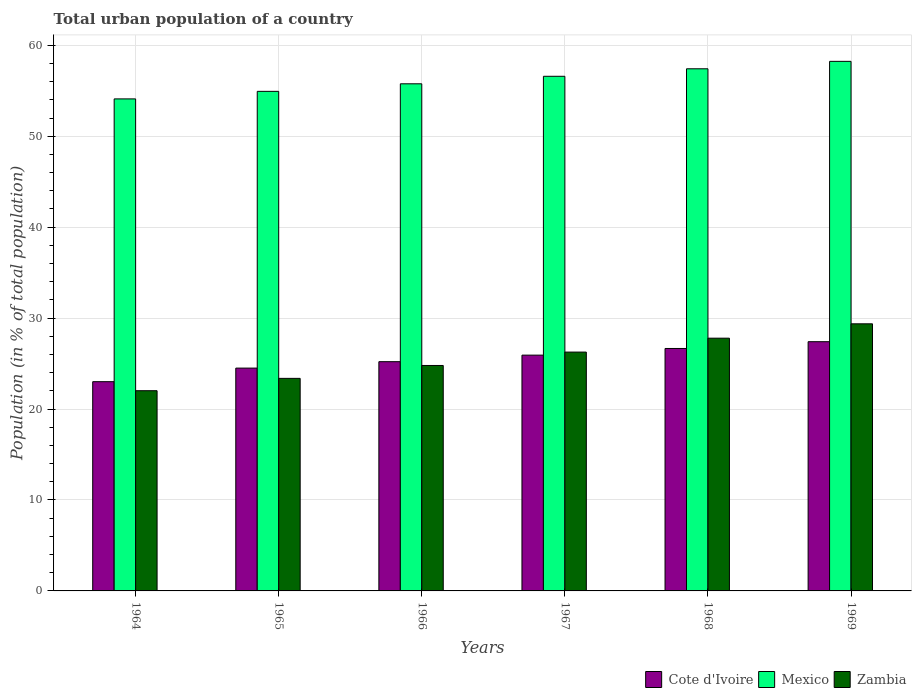How many different coloured bars are there?
Your answer should be very brief. 3. How many groups of bars are there?
Your response must be concise. 6. How many bars are there on the 3rd tick from the right?
Your answer should be compact. 3. What is the label of the 1st group of bars from the left?
Your response must be concise. 1964. In how many cases, is the number of bars for a given year not equal to the number of legend labels?
Keep it short and to the point. 0. What is the urban population in Cote d'Ivoire in 1967?
Make the answer very short. 25.93. Across all years, what is the maximum urban population in Cote d'Ivoire?
Offer a very short reply. 27.4. Across all years, what is the minimum urban population in Cote d'Ivoire?
Ensure brevity in your answer.  23.01. In which year was the urban population in Zambia maximum?
Offer a very short reply. 1969. In which year was the urban population in Mexico minimum?
Your answer should be compact. 1964. What is the total urban population in Mexico in the graph?
Make the answer very short. 337.02. What is the difference between the urban population in Mexico in 1967 and that in 1969?
Offer a terse response. -1.64. What is the difference between the urban population in Mexico in 1969 and the urban population in Zambia in 1964?
Keep it short and to the point. 36.21. What is the average urban population in Mexico per year?
Ensure brevity in your answer.  56.17. In the year 1965, what is the difference between the urban population in Cote d'Ivoire and urban population in Mexico?
Keep it short and to the point. -30.43. What is the ratio of the urban population in Cote d'Ivoire in 1965 to that in 1966?
Offer a very short reply. 0.97. Is the urban population in Mexico in 1964 less than that in 1965?
Provide a short and direct response. Yes. What is the difference between the highest and the second highest urban population in Mexico?
Give a very brief answer. 0.82. What is the difference between the highest and the lowest urban population in Zambia?
Offer a terse response. 7.36. What does the 1st bar from the left in 1966 represents?
Provide a succinct answer. Cote d'Ivoire. What does the 1st bar from the right in 1969 represents?
Your response must be concise. Zambia. How many bars are there?
Provide a succinct answer. 18. Are all the bars in the graph horizontal?
Your response must be concise. No. What is the difference between two consecutive major ticks on the Y-axis?
Offer a very short reply. 10. Are the values on the major ticks of Y-axis written in scientific E-notation?
Give a very brief answer. No. Does the graph contain any zero values?
Your answer should be compact. No. Does the graph contain grids?
Offer a terse response. Yes. How are the legend labels stacked?
Provide a short and direct response. Horizontal. What is the title of the graph?
Provide a succinct answer. Total urban population of a country. What is the label or title of the X-axis?
Offer a terse response. Years. What is the label or title of the Y-axis?
Your response must be concise. Population (in % of total population). What is the Population (in % of total population) of Cote d'Ivoire in 1964?
Give a very brief answer. 23.01. What is the Population (in % of total population) in Mexico in 1964?
Ensure brevity in your answer.  54.1. What is the Population (in % of total population) of Zambia in 1964?
Provide a succinct answer. 22.02. What is the Population (in % of total population) of Cote d'Ivoire in 1965?
Your response must be concise. 24.5. What is the Population (in % of total population) in Mexico in 1965?
Your response must be concise. 54.93. What is the Population (in % of total population) in Zambia in 1965?
Keep it short and to the point. 23.37. What is the Population (in % of total population) of Cote d'Ivoire in 1966?
Offer a terse response. 25.21. What is the Population (in % of total population) of Mexico in 1966?
Offer a very short reply. 55.76. What is the Population (in % of total population) of Zambia in 1966?
Keep it short and to the point. 24.79. What is the Population (in % of total population) of Cote d'Ivoire in 1967?
Your answer should be very brief. 25.93. What is the Population (in % of total population) in Mexico in 1967?
Provide a short and direct response. 56.59. What is the Population (in % of total population) in Zambia in 1967?
Give a very brief answer. 26.26. What is the Population (in % of total population) in Cote d'Ivoire in 1968?
Your response must be concise. 26.66. What is the Population (in % of total population) of Mexico in 1968?
Offer a terse response. 57.41. What is the Population (in % of total population) in Zambia in 1968?
Give a very brief answer. 27.79. What is the Population (in % of total population) in Cote d'Ivoire in 1969?
Offer a terse response. 27.4. What is the Population (in % of total population) of Mexico in 1969?
Offer a terse response. 58.23. What is the Population (in % of total population) of Zambia in 1969?
Your response must be concise. 29.37. Across all years, what is the maximum Population (in % of total population) in Cote d'Ivoire?
Make the answer very short. 27.4. Across all years, what is the maximum Population (in % of total population) in Mexico?
Make the answer very short. 58.23. Across all years, what is the maximum Population (in % of total population) of Zambia?
Your answer should be very brief. 29.37. Across all years, what is the minimum Population (in % of total population) in Cote d'Ivoire?
Make the answer very short. 23.01. Across all years, what is the minimum Population (in % of total population) in Mexico?
Give a very brief answer. 54.1. Across all years, what is the minimum Population (in % of total population) of Zambia?
Provide a short and direct response. 22.02. What is the total Population (in % of total population) of Cote d'Ivoire in the graph?
Your answer should be very brief. 152.7. What is the total Population (in % of total population) in Mexico in the graph?
Your answer should be very brief. 337.02. What is the total Population (in % of total population) of Zambia in the graph?
Keep it short and to the point. 153.6. What is the difference between the Population (in % of total population) in Cote d'Ivoire in 1964 and that in 1965?
Make the answer very short. -1.49. What is the difference between the Population (in % of total population) in Mexico in 1964 and that in 1965?
Ensure brevity in your answer.  -0.83. What is the difference between the Population (in % of total population) of Zambia in 1964 and that in 1965?
Give a very brief answer. -1.36. What is the difference between the Population (in % of total population) of Cote d'Ivoire in 1964 and that in 1966?
Your answer should be very brief. -2.2. What is the difference between the Population (in % of total population) in Mexico in 1964 and that in 1966?
Offer a very short reply. -1.66. What is the difference between the Population (in % of total population) of Zambia in 1964 and that in 1966?
Provide a short and direct response. -2.77. What is the difference between the Population (in % of total population) in Cote d'Ivoire in 1964 and that in 1967?
Your answer should be compact. -2.92. What is the difference between the Population (in % of total population) in Mexico in 1964 and that in 1967?
Make the answer very short. -2.49. What is the difference between the Population (in % of total population) in Zambia in 1964 and that in 1967?
Provide a succinct answer. -4.25. What is the difference between the Population (in % of total population) in Cote d'Ivoire in 1964 and that in 1968?
Your response must be concise. -3.65. What is the difference between the Population (in % of total population) of Mexico in 1964 and that in 1968?
Provide a short and direct response. -3.31. What is the difference between the Population (in % of total population) of Zambia in 1964 and that in 1968?
Your answer should be very brief. -5.78. What is the difference between the Population (in % of total population) of Cote d'Ivoire in 1964 and that in 1969?
Offer a terse response. -4.4. What is the difference between the Population (in % of total population) of Mexico in 1964 and that in 1969?
Offer a very short reply. -4.13. What is the difference between the Population (in % of total population) in Zambia in 1964 and that in 1969?
Keep it short and to the point. -7.36. What is the difference between the Population (in % of total population) of Cote d'Ivoire in 1965 and that in 1966?
Give a very brief answer. -0.71. What is the difference between the Population (in % of total population) of Mexico in 1965 and that in 1966?
Offer a terse response. -0.83. What is the difference between the Population (in % of total population) in Zambia in 1965 and that in 1966?
Provide a succinct answer. -1.42. What is the difference between the Population (in % of total population) of Cote d'Ivoire in 1965 and that in 1967?
Ensure brevity in your answer.  -1.43. What is the difference between the Population (in % of total population) of Mexico in 1965 and that in 1967?
Offer a terse response. -1.66. What is the difference between the Population (in % of total population) in Zambia in 1965 and that in 1967?
Provide a short and direct response. -2.89. What is the difference between the Population (in % of total population) in Cote d'Ivoire in 1965 and that in 1968?
Give a very brief answer. -2.16. What is the difference between the Population (in % of total population) of Mexico in 1965 and that in 1968?
Make the answer very short. -2.48. What is the difference between the Population (in % of total population) of Zambia in 1965 and that in 1968?
Your answer should be compact. -4.42. What is the difference between the Population (in % of total population) of Cote d'Ivoire in 1965 and that in 1969?
Keep it short and to the point. -2.9. What is the difference between the Population (in % of total population) in Mexico in 1965 and that in 1969?
Your response must be concise. -3.3. What is the difference between the Population (in % of total population) in Zambia in 1965 and that in 1969?
Offer a terse response. -6. What is the difference between the Population (in % of total population) of Cote d'Ivoire in 1966 and that in 1967?
Keep it short and to the point. -0.72. What is the difference between the Population (in % of total population) in Mexico in 1966 and that in 1967?
Your response must be concise. -0.83. What is the difference between the Population (in % of total population) of Zambia in 1966 and that in 1967?
Your answer should be compact. -1.47. What is the difference between the Population (in % of total population) in Cote d'Ivoire in 1966 and that in 1968?
Give a very brief answer. -1.45. What is the difference between the Population (in % of total population) of Mexico in 1966 and that in 1968?
Your response must be concise. -1.65. What is the difference between the Population (in % of total population) in Zambia in 1966 and that in 1968?
Provide a short and direct response. -3. What is the difference between the Population (in % of total population) in Cote d'Ivoire in 1966 and that in 1969?
Ensure brevity in your answer.  -2.2. What is the difference between the Population (in % of total population) in Mexico in 1966 and that in 1969?
Offer a terse response. -2.47. What is the difference between the Population (in % of total population) of Zambia in 1966 and that in 1969?
Your answer should be very brief. -4.58. What is the difference between the Population (in % of total population) in Cote d'Ivoire in 1967 and that in 1968?
Make the answer very short. -0.73. What is the difference between the Population (in % of total population) in Mexico in 1967 and that in 1968?
Offer a terse response. -0.82. What is the difference between the Population (in % of total population) of Zambia in 1967 and that in 1968?
Ensure brevity in your answer.  -1.53. What is the difference between the Population (in % of total population) of Cote d'Ivoire in 1967 and that in 1969?
Provide a succinct answer. -1.48. What is the difference between the Population (in % of total population) of Mexico in 1967 and that in 1969?
Your answer should be very brief. -1.64. What is the difference between the Population (in % of total population) of Zambia in 1967 and that in 1969?
Provide a short and direct response. -3.11. What is the difference between the Population (in % of total population) of Cote d'Ivoire in 1968 and that in 1969?
Make the answer very short. -0.74. What is the difference between the Population (in % of total population) of Mexico in 1968 and that in 1969?
Offer a very short reply. -0.82. What is the difference between the Population (in % of total population) in Zambia in 1968 and that in 1969?
Keep it short and to the point. -1.58. What is the difference between the Population (in % of total population) in Cote d'Ivoire in 1964 and the Population (in % of total population) in Mexico in 1965?
Give a very brief answer. -31.92. What is the difference between the Population (in % of total population) of Cote d'Ivoire in 1964 and the Population (in % of total population) of Zambia in 1965?
Provide a short and direct response. -0.36. What is the difference between the Population (in % of total population) in Mexico in 1964 and the Population (in % of total population) in Zambia in 1965?
Your answer should be compact. 30.73. What is the difference between the Population (in % of total population) in Cote d'Ivoire in 1964 and the Population (in % of total population) in Mexico in 1966?
Provide a short and direct response. -32.75. What is the difference between the Population (in % of total population) in Cote d'Ivoire in 1964 and the Population (in % of total population) in Zambia in 1966?
Provide a succinct answer. -1.78. What is the difference between the Population (in % of total population) of Mexico in 1964 and the Population (in % of total population) of Zambia in 1966?
Give a very brief answer. 29.31. What is the difference between the Population (in % of total population) in Cote d'Ivoire in 1964 and the Population (in % of total population) in Mexico in 1967?
Offer a terse response. -33.58. What is the difference between the Population (in % of total population) of Cote d'Ivoire in 1964 and the Population (in % of total population) of Zambia in 1967?
Make the answer very short. -3.25. What is the difference between the Population (in % of total population) of Mexico in 1964 and the Population (in % of total population) of Zambia in 1967?
Offer a very short reply. 27.84. What is the difference between the Population (in % of total population) of Cote d'Ivoire in 1964 and the Population (in % of total population) of Mexico in 1968?
Offer a very short reply. -34.4. What is the difference between the Population (in % of total population) of Cote d'Ivoire in 1964 and the Population (in % of total population) of Zambia in 1968?
Provide a succinct answer. -4.78. What is the difference between the Population (in % of total population) of Mexico in 1964 and the Population (in % of total population) of Zambia in 1968?
Your answer should be compact. 26.31. What is the difference between the Population (in % of total population) in Cote d'Ivoire in 1964 and the Population (in % of total population) in Mexico in 1969?
Ensure brevity in your answer.  -35.22. What is the difference between the Population (in % of total population) of Cote d'Ivoire in 1964 and the Population (in % of total population) of Zambia in 1969?
Your answer should be compact. -6.36. What is the difference between the Population (in % of total population) of Mexico in 1964 and the Population (in % of total population) of Zambia in 1969?
Give a very brief answer. 24.73. What is the difference between the Population (in % of total population) in Cote d'Ivoire in 1965 and the Population (in % of total population) in Mexico in 1966?
Keep it short and to the point. -31.26. What is the difference between the Population (in % of total population) of Cote d'Ivoire in 1965 and the Population (in % of total population) of Zambia in 1966?
Provide a short and direct response. -0.29. What is the difference between the Population (in % of total population) of Mexico in 1965 and the Population (in % of total population) of Zambia in 1966?
Ensure brevity in your answer.  30.14. What is the difference between the Population (in % of total population) in Cote d'Ivoire in 1965 and the Population (in % of total population) in Mexico in 1967?
Offer a very short reply. -32.09. What is the difference between the Population (in % of total population) of Cote d'Ivoire in 1965 and the Population (in % of total population) of Zambia in 1967?
Offer a very short reply. -1.76. What is the difference between the Population (in % of total population) of Mexico in 1965 and the Population (in % of total population) of Zambia in 1967?
Provide a succinct answer. 28.67. What is the difference between the Population (in % of total population) in Cote d'Ivoire in 1965 and the Population (in % of total population) in Mexico in 1968?
Offer a terse response. -32.91. What is the difference between the Population (in % of total population) in Cote d'Ivoire in 1965 and the Population (in % of total population) in Zambia in 1968?
Provide a succinct answer. -3.29. What is the difference between the Population (in % of total population) of Mexico in 1965 and the Population (in % of total population) of Zambia in 1968?
Your answer should be very brief. 27.14. What is the difference between the Population (in % of total population) of Cote d'Ivoire in 1965 and the Population (in % of total population) of Mexico in 1969?
Offer a very short reply. -33.73. What is the difference between the Population (in % of total population) of Cote d'Ivoire in 1965 and the Population (in % of total population) of Zambia in 1969?
Your response must be concise. -4.87. What is the difference between the Population (in % of total population) in Mexico in 1965 and the Population (in % of total population) in Zambia in 1969?
Make the answer very short. 25.56. What is the difference between the Population (in % of total population) in Cote d'Ivoire in 1966 and the Population (in % of total population) in Mexico in 1967?
Provide a short and direct response. -31.38. What is the difference between the Population (in % of total population) of Cote d'Ivoire in 1966 and the Population (in % of total population) of Zambia in 1967?
Provide a succinct answer. -1.05. What is the difference between the Population (in % of total population) of Mexico in 1966 and the Population (in % of total population) of Zambia in 1967?
Your answer should be compact. 29.5. What is the difference between the Population (in % of total population) of Cote d'Ivoire in 1966 and the Population (in % of total population) of Mexico in 1968?
Your answer should be very brief. -32.2. What is the difference between the Population (in % of total population) in Cote d'Ivoire in 1966 and the Population (in % of total population) in Zambia in 1968?
Your response must be concise. -2.58. What is the difference between the Population (in % of total population) of Mexico in 1966 and the Population (in % of total population) of Zambia in 1968?
Your answer should be very brief. 27.97. What is the difference between the Population (in % of total population) in Cote d'Ivoire in 1966 and the Population (in % of total population) in Mexico in 1969?
Keep it short and to the point. -33.02. What is the difference between the Population (in % of total population) of Cote d'Ivoire in 1966 and the Population (in % of total population) of Zambia in 1969?
Your answer should be very brief. -4.16. What is the difference between the Population (in % of total population) of Mexico in 1966 and the Population (in % of total population) of Zambia in 1969?
Provide a succinct answer. 26.39. What is the difference between the Population (in % of total population) in Cote d'Ivoire in 1967 and the Population (in % of total population) in Mexico in 1968?
Provide a succinct answer. -31.48. What is the difference between the Population (in % of total population) in Cote d'Ivoire in 1967 and the Population (in % of total population) in Zambia in 1968?
Keep it short and to the point. -1.86. What is the difference between the Population (in % of total population) in Mexico in 1967 and the Population (in % of total population) in Zambia in 1968?
Offer a very short reply. 28.8. What is the difference between the Population (in % of total population) of Cote d'Ivoire in 1967 and the Population (in % of total population) of Mexico in 1969?
Your response must be concise. -32.3. What is the difference between the Population (in % of total population) in Cote d'Ivoire in 1967 and the Population (in % of total population) in Zambia in 1969?
Ensure brevity in your answer.  -3.44. What is the difference between the Population (in % of total population) in Mexico in 1967 and the Population (in % of total population) in Zambia in 1969?
Your answer should be compact. 27.22. What is the difference between the Population (in % of total population) of Cote d'Ivoire in 1968 and the Population (in % of total population) of Mexico in 1969?
Provide a short and direct response. -31.57. What is the difference between the Population (in % of total population) in Cote d'Ivoire in 1968 and the Population (in % of total population) in Zambia in 1969?
Give a very brief answer. -2.71. What is the difference between the Population (in % of total population) in Mexico in 1968 and the Population (in % of total population) in Zambia in 1969?
Offer a terse response. 28.04. What is the average Population (in % of total population) of Cote d'Ivoire per year?
Ensure brevity in your answer.  25.45. What is the average Population (in % of total population) of Mexico per year?
Keep it short and to the point. 56.17. What is the average Population (in % of total population) in Zambia per year?
Keep it short and to the point. 25.6. In the year 1964, what is the difference between the Population (in % of total population) in Cote d'Ivoire and Population (in % of total population) in Mexico?
Your response must be concise. -31.09. In the year 1964, what is the difference between the Population (in % of total population) of Cote d'Ivoire and Population (in % of total population) of Zambia?
Keep it short and to the point. 0.99. In the year 1964, what is the difference between the Population (in % of total population) in Mexico and Population (in % of total population) in Zambia?
Offer a very short reply. 32.09. In the year 1965, what is the difference between the Population (in % of total population) in Cote d'Ivoire and Population (in % of total population) in Mexico?
Make the answer very short. -30.43. In the year 1965, what is the difference between the Population (in % of total population) of Cote d'Ivoire and Population (in % of total population) of Zambia?
Make the answer very short. 1.13. In the year 1965, what is the difference between the Population (in % of total population) in Mexico and Population (in % of total population) in Zambia?
Provide a succinct answer. 31.56. In the year 1966, what is the difference between the Population (in % of total population) of Cote d'Ivoire and Population (in % of total population) of Mexico?
Your answer should be compact. -30.55. In the year 1966, what is the difference between the Population (in % of total population) of Cote d'Ivoire and Population (in % of total population) of Zambia?
Offer a very short reply. 0.42. In the year 1966, what is the difference between the Population (in % of total population) in Mexico and Population (in % of total population) in Zambia?
Provide a succinct answer. 30.97. In the year 1967, what is the difference between the Population (in % of total population) of Cote d'Ivoire and Population (in % of total population) of Mexico?
Provide a short and direct response. -30.66. In the year 1967, what is the difference between the Population (in % of total population) in Cote d'Ivoire and Population (in % of total population) in Zambia?
Offer a very short reply. -0.34. In the year 1967, what is the difference between the Population (in % of total population) of Mexico and Population (in % of total population) of Zambia?
Your answer should be very brief. 30.33. In the year 1968, what is the difference between the Population (in % of total population) of Cote d'Ivoire and Population (in % of total population) of Mexico?
Give a very brief answer. -30.75. In the year 1968, what is the difference between the Population (in % of total population) in Cote d'Ivoire and Population (in % of total population) in Zambia?
Offer a terse response. -1.13. In the year 1968, what is the difference between the Population (in % of total population) in Mexico and Population (in % of total population) in Zambia?
Give a very brief answer. 29.62. In the year 1969, what is the difference between the Population (in % of total population) of Cote d'Ivoire and Population (in % of total population) of Mexico?
Make the answer very short. -30.82. In the year 1969, what is the difference between the Population (in % of total population) in Cote d'Ivoire and Population (in % of total population) in Zambia?
Keep it short and to the point. -1.97. In the year 1969, what is the difference between the Population (in % of total population) in Mexico and Population (in % of total population) in Zambia?
Your answer should be compact. 28.86. What is the ratio of the Population (in % of total population) in Cote d'Ivoire in 1964 to that in 1965?
Keep it short and to the point. 0.94. What is the ratio of the Population (in % of total population) of Mexico in 1964 to that in 1965?
Offer a very short reply. 0.98. What is the ratio of the Population (in % of total population) in Zambia in 1964 to that in 1965?
Your answer should be compact. 0.94. What is the ratio of the Population (in % of total population) in Cote d'Ivoire in 1964 to that in 1966?
Provide a short and direct response. 0.91. What is the ratio of the Population (in % of total population) of Mexico in 1964 to that in 1966?
Offer a very short reply. 0.97. What is the ratio of the Population (in % of total population) of Zambia in 1964 to that in 1966?
Provide a short and direct response. 0.89. What is the ratio of the Population (in % of total population) of Cote d'Ivoire in 1964 to that in 1967?
Offer a terse response. 0.89. What is the ratio of the Population (in % of total population) of Mexico in 1964 to that in 1967?
Your response must be concise. 0.96. What is the ratio of the Population (in % of total population) in Zambia in 1964 to that in 1967?
Provide a succinct answer. 0.84. What is the ratio of the Population (in % of total population) of Cote d'Ivoire in 1964 to that in 1968?
Offer a very short reply. 0.86. What is the ratio of the Population (in % of total population) in Mexico in 1964 to that in 1968?
Ensure brevity in your answer.  0.94. What is the ratio of the Population (in % of total population) of Zambia in 1964 to that in 1968?
Offer a very short reply. 0.79. What is the ratio of the Population (in % of total population) of Cote d'Ivoire in 1964 to that in 1969?
Ensure brevity in your answer.  0.84. What is the ratio of the Population (in % of total population) of Mexico in 1964 to that in 1969?
Make the answer very short. 0.93. What is the ratio of the Population (in % of total population) of Zambia in 1964 to that in 1969?
Make the answer very short. 0.75. What is the ratio of the Population (in % of total population) of Cote d'Ivoire in 1965 to that in 1966?
Make the answer very short. 0.97. What is the ratio of the Population (in % of total population) in Mexico in 1965 to that in 1966?
Make the answer very short. 0.99. What is the ratio of the Population (in % of total population) in Zambia in 1965 to that in 1966?
Give a very brief answer. 0.94. What is the ratio of the Population (in % of total population) in Cote d'Ivoire in 1965 to that in 1967?
Your answer should be compact. 0.94. What is the ratio of the Population (in % of total population) in Mexico in 1965 to that in 1967?
Provide a short and direct response. 0.97. What is the ratio of the Population (in % of total population) of Zambia in 1965 to that in 1967?
Offer a terse response. 0.89. What is the ratio of the Population (in % of total population) in Cote d'Ivoire in 1965 to that in 1968?
Provide a short and direct response. 0.92. What is the ratio of the Population (in % of total population) of Mexico in 1965 to that in 1968?
Provide a short and direct response. 0.96. What is the ratio of the Population (in % of total population) of Zambia in 1965 to that in 1968?
Give a very brief answer. 0.84. What is the ratio of the Population (in % of total population) of Cote d'Ivoire in 1965 to that in 1969?
Keep it short and to the point. 0.89. What is the ratio of the Population (in % of total population) of Mexico in 1965 to that in 1969?
Provide a succinct answer. 0.94. What is the ratio of the Population (in % of total population) of Zambia in 1965 to that in 1969?
Offer a terse response. 0.8. What is the ratio of the Population (in % of total population) of Cote d'Ivoire in 1966 to that in 1967?
Provide a short and direct response. 0.97. What is the ratio of the Population (in % of total population) in Mexico in 1966 to that in 1967?
Your response must be concise. 0.99. What is the ratio of the Population (in % of total population) in Zambia in 1966 to that in 1967?
Provide a succinct answer. 0.94. What is the ratio of the Population (in % of total population) in Cote d'Ivoire in 1966 to that in 1968?
Make the answer very short. 0.95. What is the ratio of the Population (in % of total population) in Mexico in 1966 to that in 1968?
Provide a succinct answer. 0.97. What is the ratio of the Population (in % of total population) in Zambia in 1966 to that in 1968?
Give a very brief answer. 0.89. What is the ratio of the Population (in % of total population) in Cote d'Ivoire in 1966 to that in 1969?
Provide a succinct answer. 0.92. What is the ratio of the Population (in % of total population) in Mexico in 1966 to that in 1969?
Make the answer very short. 0.96. What is the ratio of the Population (in % of total population) in Zambia in 1966 to that in 1969?
Your answer should be very brief. 0.84. What is the ratio of the Population (in % of total population) of Cote d'Ivoire in 1967 to that in 1968?
Your answer should be very brief. 0.97. What is the ratio of the Population (in % of total population) of Mexico in 1967 to that in 1968?
Your answer should be compact. 0.99. What is the ratio of the Population (in % of total population) in Zambia in 1967 to that in 1968?
Give a very brief answer. 0.94. What is the ratio of the Population (in % of total population) of Cote d'Ivoire in 1967 to that in 1969?
Keep it short and to the point. 0.95. What is the ratio of the Population (in % of total population) of Mexico in 1967 to that in 1969?
Make the answer very short. 0.97. What is the ratio of the Population (in % of total population) in Zambia in 1967 to that in 1969?
Provide a succinct answer. 0.89. What is the ratio of the Population (in % of total population) of Cote d'Ivoire in 1968 to that in 1969?
Ensure brevity in your answer.  0.97. What is the ratio of the Population (in % of total population) in Zambia in 1968 to that in 1969?
Your answer should be compact. 0.95. What is the difference between the highest and the second highest Population (in % of total population) in Cote d'Ivoire?
Provide a succinct answer. 0.74. What is the difference between the highest and the second highest Population (in % of total population) in Mexico?
Ensure brevity in your answer.  0.82. What is the difference between the highest and the second highest Population (in % of total population) of Zambia?
Make the answer very short. 1.58. What is the difference between the highest and the lowest Population (in % of total population) of Cote d'Ivoire?
Give a very brief answer. 4.4. What is the difference between the highest and the lowest Population (in % of total population) of Mexico?
Provide a succinct answer. 4.13. What is the difference between the highest and the lowest Population (in % of total population) in Zambia?
Give a very brief answer. 7.36. 